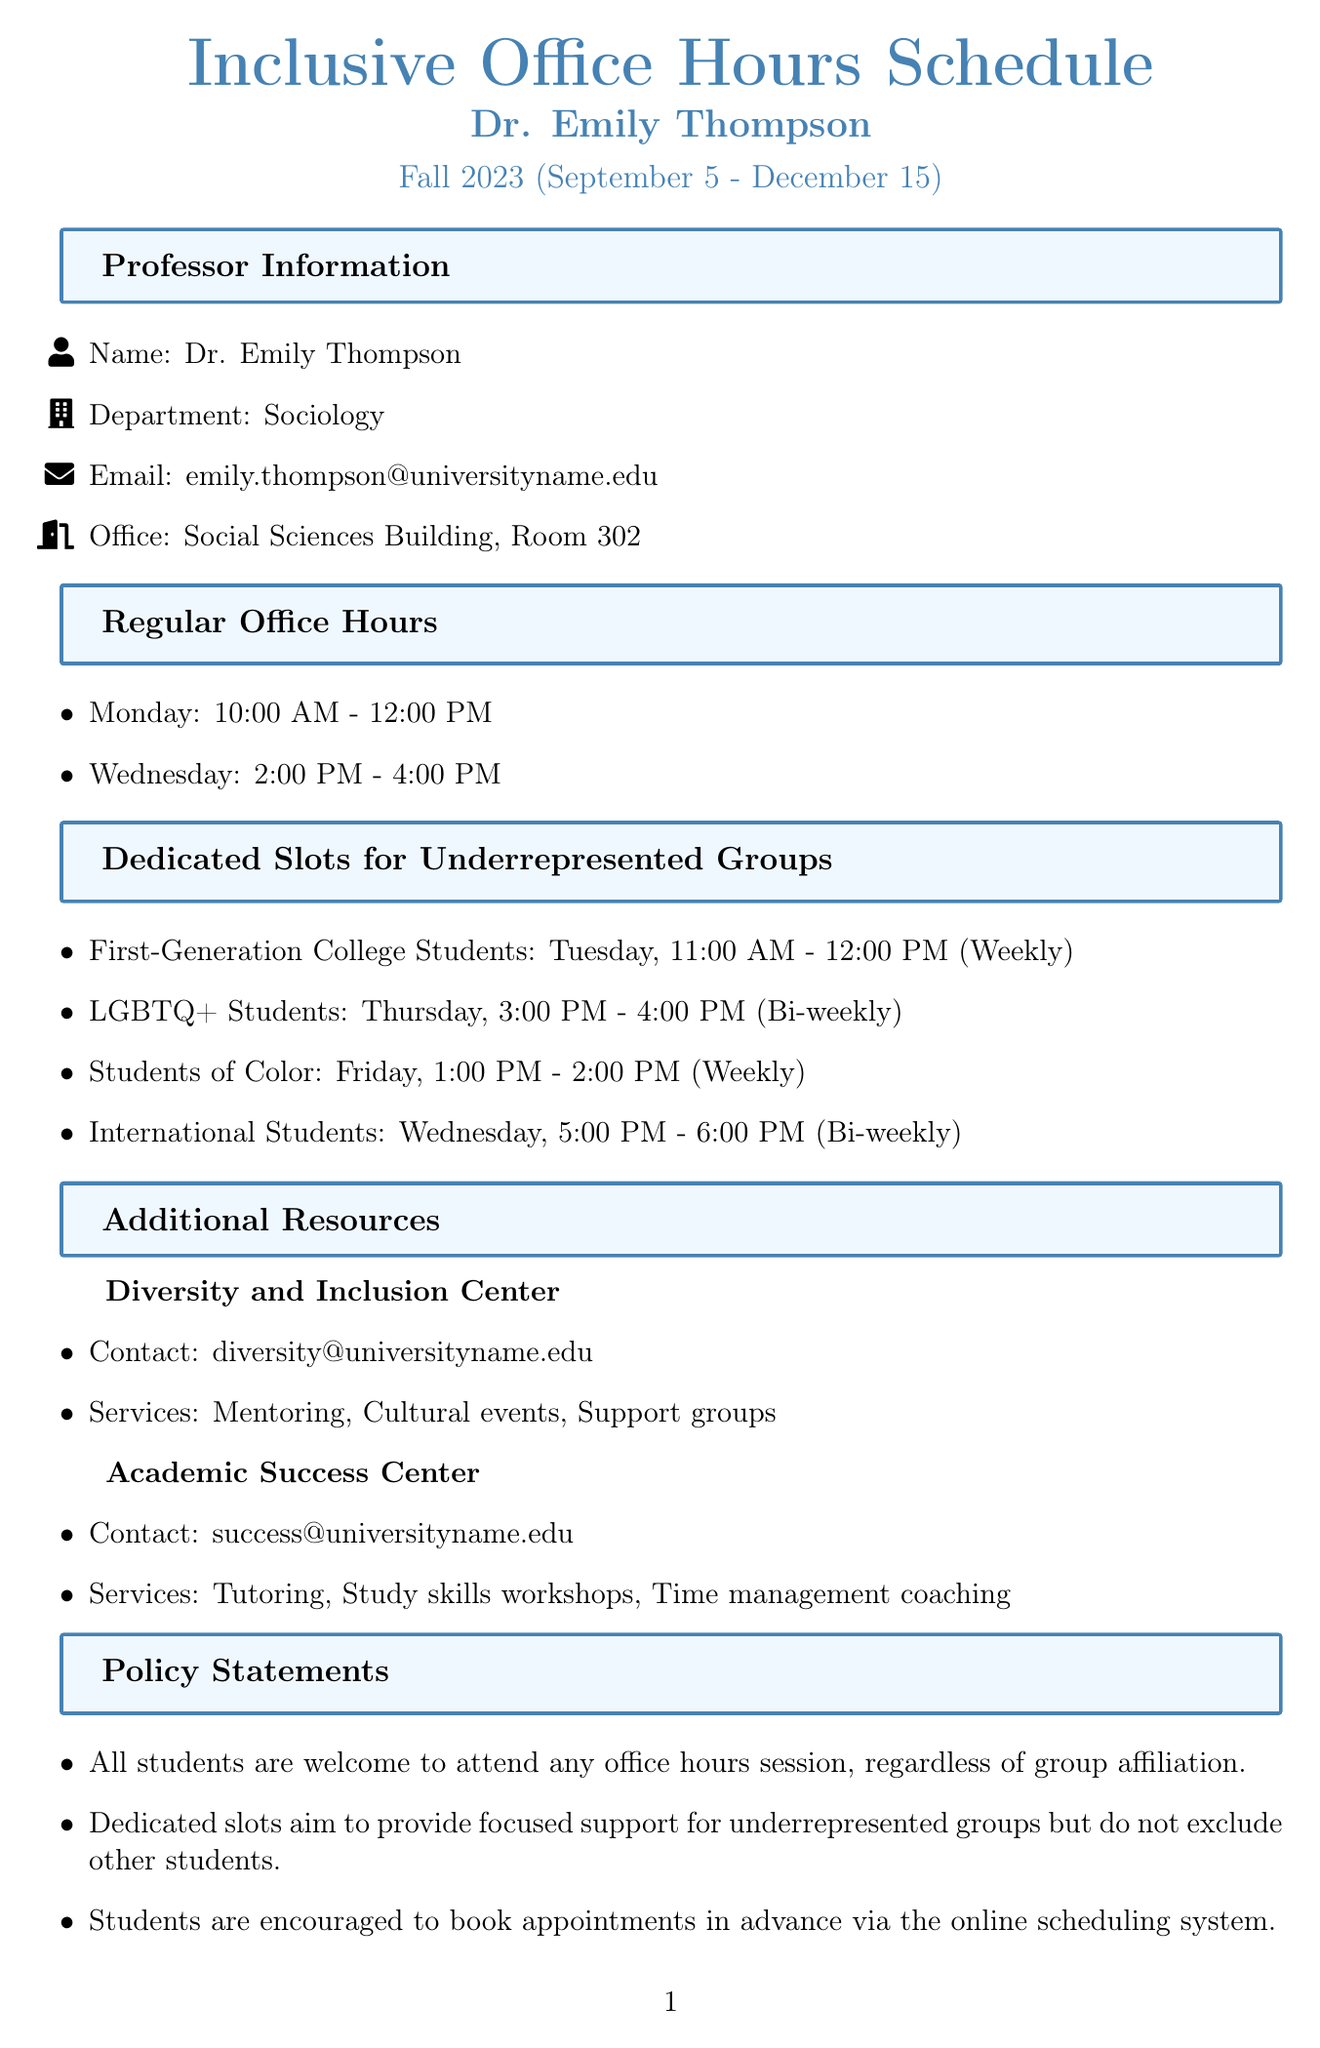What is the office location of Dr. Emily Thompson? Dr. Emily Thompson's office is located in the Social Sciences Building, Room 302.
Answer: Social Sciences Building, Room 302 What days are the regular office hours held? Regular office hours are scheduled on Monday and Wednesday as mentioned in the document.
Answer: Monday, Wednesday What group has dedicated office hours on Tuesday? The dedicated slot for Tuesday is specifically for First-Generation College Students.
Answer: First-Generation College Students How often do LGBTQ+ Students have dedicated office hours? The frequency of dedicated office hours for LGBTQ+ Students is mentioned as bi-weekly in the document.
Answer: Bi-weekly What additional resource focuses on diversity support? The document lists the Diversity and Inclusion Center as a resource that focuses on diversity support.
Answer: Diversity and Inclusion Center How many equality initiatives are mentioned in the document? The document provides a list of equality initiatives that includes three specific initiatives.
Answer: Three What time is the dedicated slot for Students of Color? The document specifies that the dedicated slot for Students of Color is held from 1:00 PM to 2:00 PM on Fridays.
Answer: 1:00 PM - 2:00 PM What is encouraged concerning booking appointments? The document advises students to book appointments in advance via the online scheduling system.
Answer: Book appointments in advance What is the frequency of office hours for International Students? The schedule indicates the frequency for International Students' dedicated hours as bi-weekly.
Answer: Bi-weekly 